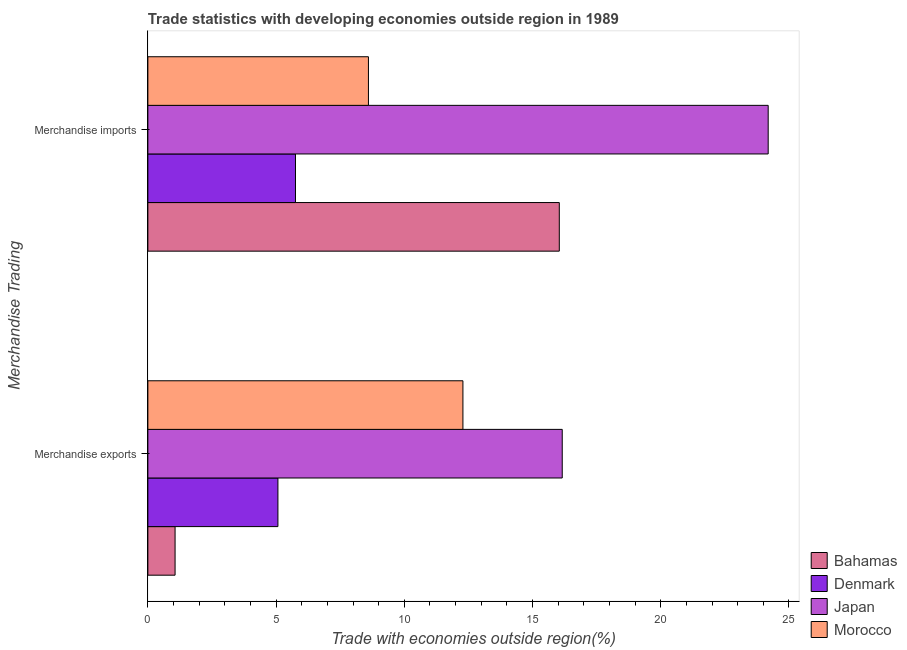How many groups of bars are there?
Your response must be concise. 2. Are the number of bars per tick equal to the number of legend labels?
Offer a very short reply. Yes. Are the number of bars on each tick of the Y-axis equal?
Your response must be concise. Yes. What is the label of the 1st group of bars from the top?
Keep it short and to the point. Merchandise imports. What is the merchandise exports in Denmark?
Your answer should be compact. 5.07. Across all countries, what is the maximum merchandise exports?
Offer a very short reply. 16.16. Across all countries, what is the minimum merchandise exports?
Your response must be concise. 1.06. In which country was the merchandise exports minimum?
Provide a short and direct response. Bahamas. What is the total merchandise imports in the graph?
Offer a very short reply. 54.59. What is the difference between the merchandise exports in Denmark and that in Japan?
Offer a terse response. -11.09. What is the difference between the merchandise imports in Morocco and the merchandise exports in Denmark?
Your answer should be very brief. 3.53. What is the average merchandise imports per country?
Your answer should be compact. 13.65. What is the difference between the merchandise imports and merchandise exports in Morocco?
Make the answer very short. -3.68. What is the ratio of the merchandise exports in Morocco to that in Japan?
Offer a terse response. 0.76. What does the 1st bar from the bottom in Merchandise imports represents?
Your response must be concise. Bahamas. What is the difference between two consecutive major ticks on the X-axis?
Provide a succinct answer. 5. What is the title of the graph?
Ensure brevity in your answer.  Trade statistics with developing economies outside region in 1989. What is the label or title of the X-axis?
Your answer should be very brief. Trade with economies outside region(%). What is the label or title of the Y-axis?
Your answer should be very brief. Merchandise Trading. What is the Trade with economies outside region(%) of Bahamas in Merchandise exports?
Offer a terse response. 1.06. What is the Trade with economies outside region(%) of Denmark in Merchandise exports?
Your answer should be compact. 5.07. What is the Trade with economies outside region(%) of Japan in Merchandise exports?
Keep it short and to the point. 16.16. What is the Trade with economies outside region(%) in Morocco in Merchandise exports?
Offer a terse response. 12.29. What is the Trade with economies outside region(%) in Bahamas in Merchandise imports?
Your answer should be compact. 16.04. What is the Trade with economies outside region(%) of Denmark in Merchandise imports?
Offer a terse response. 5.76. What is the Trade with economies outside region(%) of Japan in Merchandise imports?
Provide a succinct answer. 24.19. What is the Trade with economies outside region(%) of Morocco in Merchandise imports?
Your answer should be compact. 8.6. Across all Merchandise Trading, what is the maximum Trade with economies outside region(%) in Bahamas?
Provide a succinct answer. 16.04. Across all Merchandise Trading, what is the maximum Trade with economies outside region(%) of Denmark?
Keep it short and to the point. 5.76. Across all Merchandise Trading, what is the maximum Trade with economies outside region(%) of Japan?
Ensure brevity in your answer.  24.19. Across all Merchandise Trading, what is the maximum Trade with economies outside region(%) in Morocco?
Keep it short and to the point. 12.29. Across all Merchandise Trading, what is the minimum Trade with economies outside region(%) of Bahamas?
Offer a terse response. 1.06. Across all Merchandise Trading, what is the minimum Trade with economies outside region(%) in Denmark?
Keep it short and to the point. 5.07. Across all Merchandise Trading, what is the minimum Trade with economies outside region(%) of Japan?
Ensure brevity in your answer.  16.16. Across all Merchandise Trading, what is the minimum Trade with economies outside region(%) in Morocco?
Provide a succinct answer. 8.6. What is the total Trade with economies outside region(%) of Bahamas in the graph?
Keep it short and to the point. 17.11. What is the total Trade with economies outside region(%) of Denmark in the graph?
Provide a short and direct response. 10.83. What is the total Trade with economies outside region(%) of Japan in the graph?
Give a very brief answer. 40.35. What is the total Trade with economies outside region(%) in Morocco in the graph?
Your answer should be very brief. 20.89. What is the difference between the Trade with economies outside region(%) in Bahamas in Merchandise exports and that in Merchandise imports?
Give a very brief answer. -14.98. What is the difference between the Trade with economies outside region(%) of Denmark in Merchandise exports and that in Merchandise imports?
Keep it short and to the point. -0.69. What is the difference between the Trade with economies outside region(%) of Japan in Merchandise exports and that in Merchandise imports?
Offer a very short reply. -8.03. What is the difference between the Trade with economies outside region(%) in Morocco in Merchandise exports and that in Merchandise imports?
Your response must be concise. 3.68. What is the difference between the Trade with economies outside region(%) in Bahamas in Merchandise exports and the Trade with economies outside region(%) in Denmark in Merchandise imports?
Offer a terse response. -4.7. What is the difference between the Trade with economies outside region(%) of Bahamas in Merchandise exports and the Trade with economies outside region(%) of Japan in Merchandise imports?
Offer a very short reply. -23.13. What is the difference between the Trade with economies outside region(%) in Bahamas in Merchandise exports and the Trade with economies outside region(%) in Morocco in Merchandise imports?
Offer a terse response. -7.54. What is the difference between the Trade with economies outside region(%) in Denmark in Merchandise exports and the Trade with economies outside region(%) in Japan in Merchandise imports?
Offer a terse response. -19.12. What is the difference between the Trade with economies outside region(%) of Denmark in Merchandise exports and the Trade with economies outside region(%) of Morocco in Merchandise imports?
Offer a very short reply. -3.53. What is the difference between the Trade with economies outside region(%) of Japan in Merchandise exports and the Trade with economies outside region(%) of Morocco in Merchandise imports?
Make the answer very short. 7.56. What is the average Trade with economies outside region(%) of Bahamas per Merchandise Trading?
Make the answer very short. 8.55. What is the average Trade with economies outside region(%) in Denmark per Merchandise Trading?
Your answer should be compact. 5.41. What is the average Trade with economies outside region(%) of Japan per Merchandise Trading?
Give a very brief answer. 20.17. What is the average Trade with economies outside region(%) of Morocco per Merchandise Trading?
Your answer should be compact. 10.44. What is the difference between the Trade with economies outside region(%) in Bahamas and Trade with economies outside region(%) in Denmark in Merchandise exports?
Your answer should be very brief. -4.01. What is the difference between the Trade with economies outside region(%) of Bahamas and Trade with economies outside region(%) of Japan in Merchandise exports?
Your answer should be compact. -15.1. What is the difference between the Trade with economies outside region(%) in Bahamas and Trade with economies outside region(%) in Morocco in Merchandise exports?
Your answer should be very brief. -11.22. What is the difference between the Trade with economies outside region(%) of Denmark and Trade with economies outside region(%) of Japan in Merchandise exports?
Your answer should be compact. -11.09. What is the difference between the Trade with economies outside region(%) in Denmark and Trade with economies outside region(%) in Morocco in Merchandise exports?
Keep it short and to the point. -7.21. What is the difference between the Trade with economies outside region(%) of Japan and Trade with economies outside region(%) of Morocco in Merchandise exports?
Provide a succinct answer. 3.87. What is the difference between the Trade with economies outside region(%) of Bahamas and Trade with economies outside region(%) of Denmark in Merchandise imports?
Keep it short and to the point. 10.29. What is the difference between the Trade with economies outside region(%) of Bahamas and Trade with economies outside region(%) of Japan in Merchandise imports?
Provide a succinct answer. -8.15. What is the difference between the Trade with economies outside region(%) of Bahamas and Trade with economies outside region(%) of Morocco in Merchandise imports?
Offer a terse response. 7.44. What is the difference between the Trade with economies outside region(%) of Denmark and Trade with economies outside region(%) of Japan in Merchandise imports?
Make the answer very short. -18.43. What is the difference between the Trade with economies outside region(%) in Denmark and Trade with economies outside region(%) in Morocco in Merchandise imports?
Give a very brief answer. -2.84. What is the difference between the Trade with economies outside region(%) of Japan and Trade with economies outside region(%) of Morocco in Merchandise imports?
Make the answer very short. 15.59. What is the ratio of the Trade with economies outside region(%) of Bahamas in Merchandise exports to that in Merchandise imports?
Offer a terse response. 0.07. What is the ratio of the Trade with economies outside region(%) in Denmark in Merchandise exports to that in Merchandise imports?
Offer a very short reply. 0.88. What is the ratio of the Trade with economies outside region(%) in Japan in Merchandise exports to that in Merchandise imports?
Provide a short and direct response. 0.67. What is the ratio of the Trade with economies outside region(%) of Morocco in Merchandise exports to that in Merchandise imports?
Provide a succinct answer. 1.43. What is the difference between the highest and the second highest Trade with economies outside region(%) of Bahamas?
Ensure brevity in your answer.  14.98. What is the difference between the highest and the second highest Trade with economies outside region(%) in Denmark?
Provide a short and direct response. 0.69. What is the difference between the highest and the second highest Trade with economies outside region(%) of Japan?
Offer a terse response. 8.03. What is the difference between the highest and the second highest Trade with economies outside region(%) of Morocco?
Your response must be concise. 3.68. What is the difference between the highest and the lowest Trade with economies outside region(%) in Bahamas?
Keep it short and to the point. 14.98. What is the difference between the highest and the lowest Trade with economies outside region(%) of Denmark?
Offer a terse response. 0.69. What is the difference between the highest and the lowest Trade with economies outside region(%) of Japan?
Make the answer very short. 8.03. What is the difference between the highest and the lowest Trade with economies outside region(%) of Morocco?
Provide a short and direct response. 3.68. 